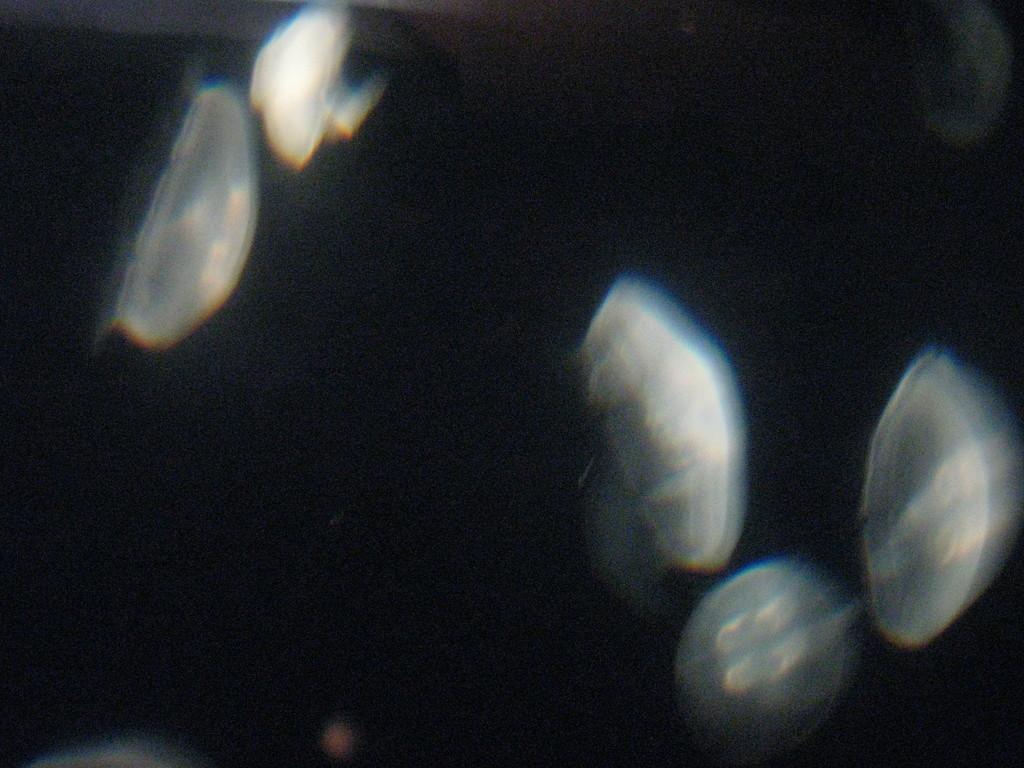Could you give a brief overview of what you see in this image? In this picture we can see some objects and in the background it is dark. 